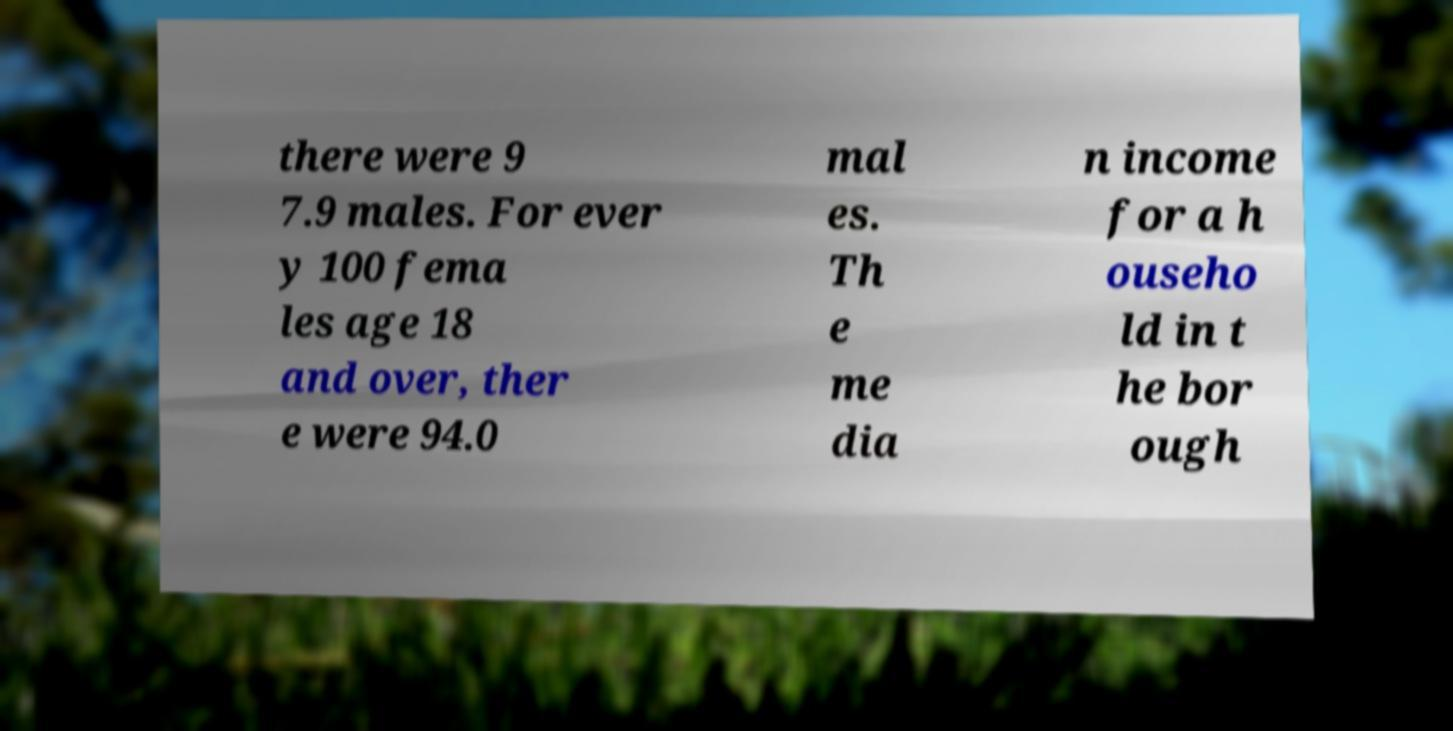Could you assist in decoding the text presented in this image and type it out clearly? there were 9 7.9 males. For ever y 100 fema les age 18 and over, ther e were 94.0 mal es. Th e me dia n income for a h ouseho ld in t he bor ough 